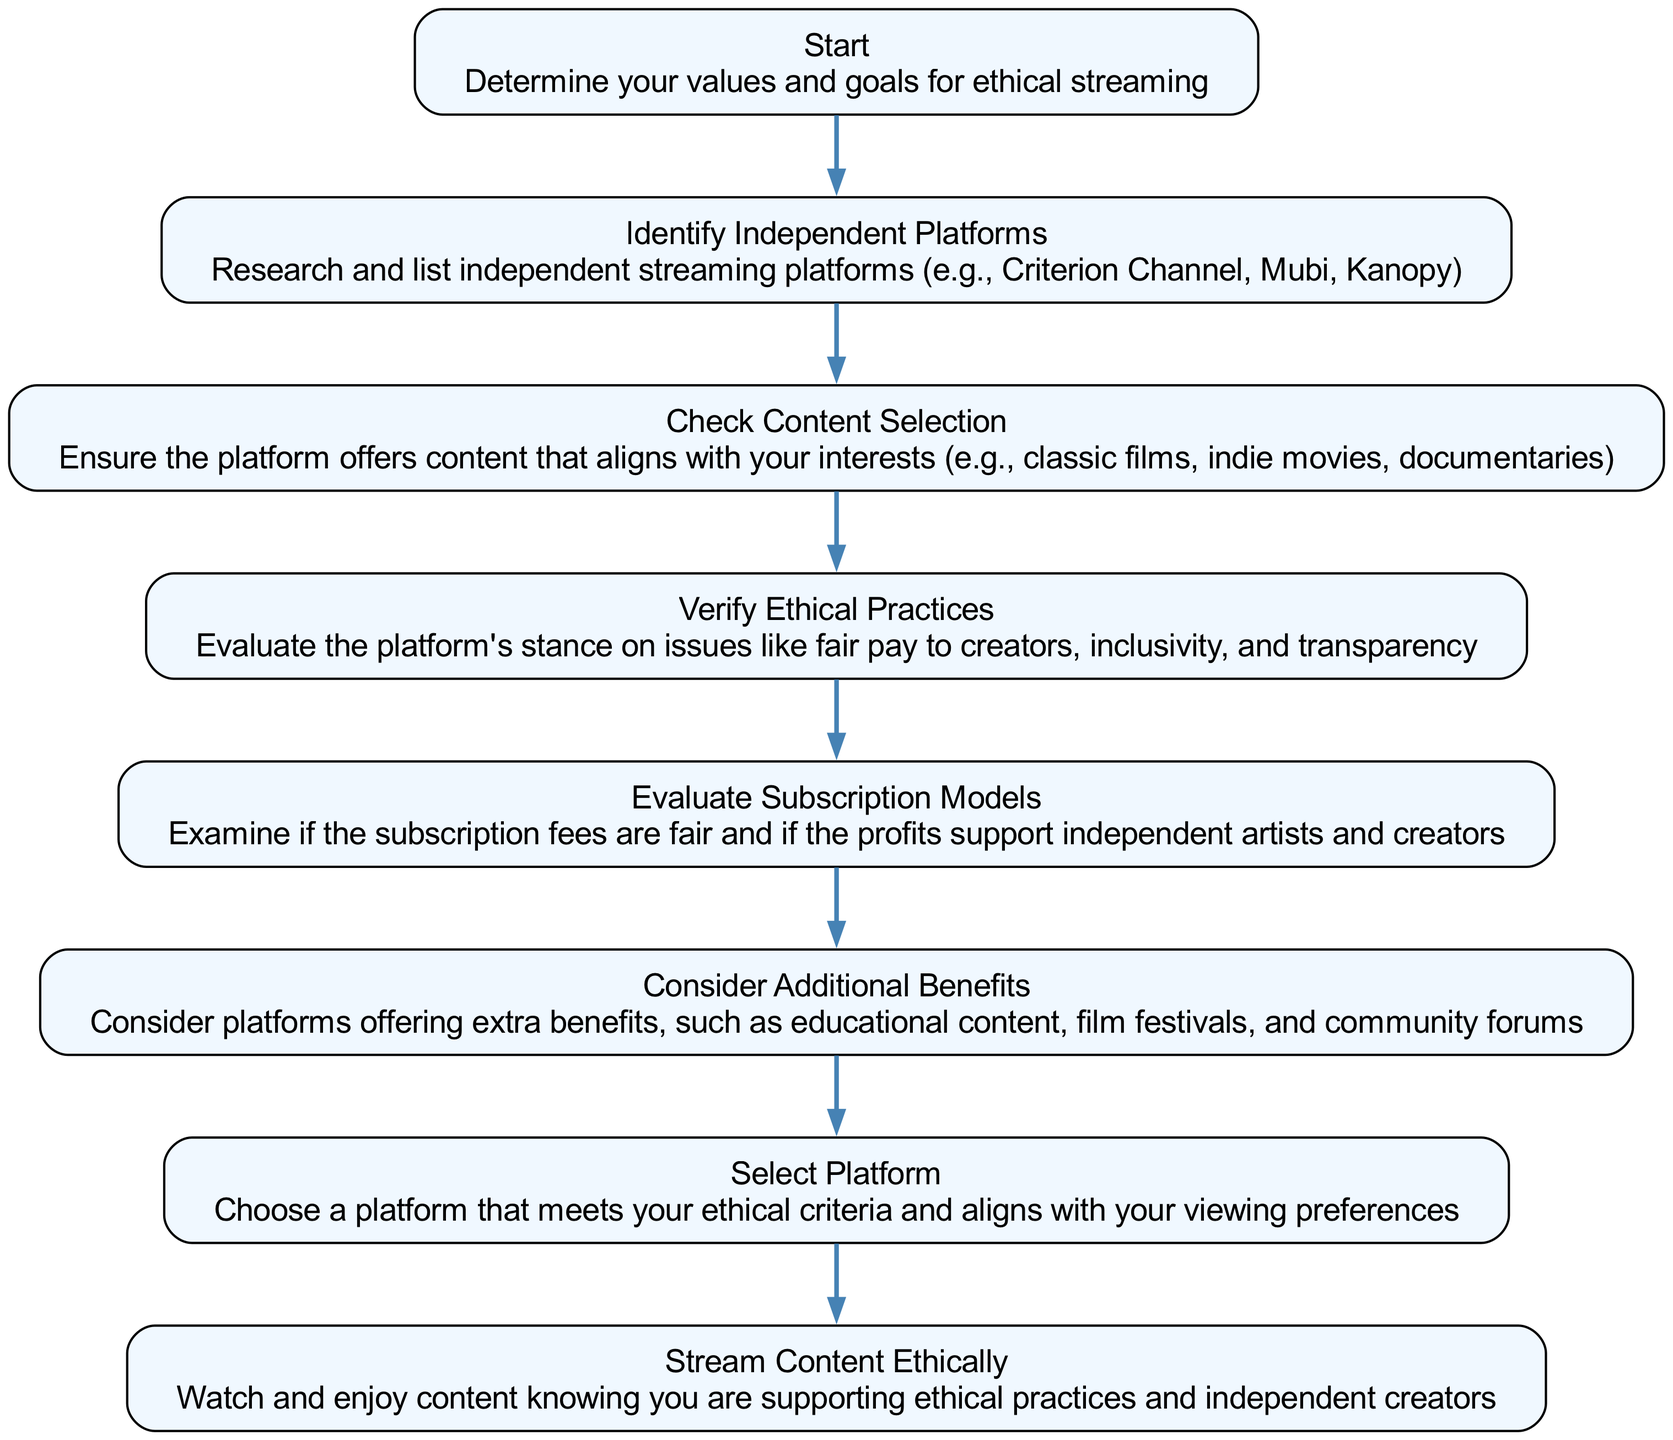What is the title of the diagram? The title of the diagram is explicitly mentioned at the top and states "Ethical Streaming Options for Conscious Viewers: Avoiding Major Corporations."
Answer: Ethical Streaming Options for Conscious Viewers: Avoiding Major Corporations How many elements are in the diagram? Counting all the nodes listed in the elements section, there are eight distinct elements in total.
Answer: 8 What is the first step in the flowchart? The flowchart begins at the "Start" node, which describes determining values and goals for ethical streaming.
Answer: Start What is the final action to take according to the diagram? The last action is represented by the "Stream Content Ethically" node, instructing viewers to watch and enjoy content while supporting ethical practices.
Answer: Stream Content Ethically Which node follows "Evaluate Subscription Models"? The node that follows "Evaluate Subscription Models" is "Consider Additional Benefits," indicating the next step in the sequence from that point.
Answer: Consider Additional Benefits What is the relationship between "Identify Independent Platforms" and "Check Content Selection"? "Identify Independent Platforms" connects to "Check Content Selection," meaning that after identifying platforms, the next step is to check the content they provide.
Answer: Check Content Selection How many connections are there in the diagram? By counting the arrows (connections) that link the elements together, there are seven connections in total that outline the flow of steps.
Answer: 7 What does the "Verify Ethical Practices" step involve? This step focuses on evaluating the platform's stance on fair pay to creators, inclusivity, and transparency, which are key ethical considerations.
Answer: Evaluate the platform's stance on ethical practices What is suggested after selecting a platform? After selecting a platform, the final suggested action is to "Stream Content Ethically," which means engaging with the content while supporting ethical streaming choices.
Answer: Stream Content Ethically 